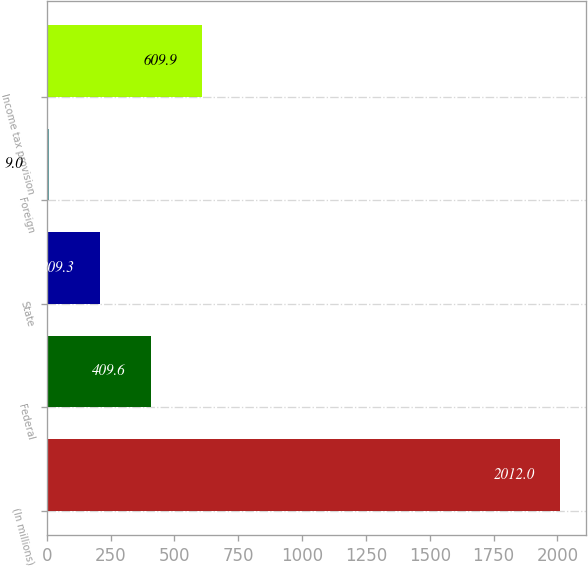<chart> <loc_0><loc_0><loc_500><loc_500><bar_chart><fcel>(In millions)<fcel>Federal<fcel>State<fcel>Foreign<fcel>Income tax provision<nl><fcel>2012<fcel>409.6<fcel>209.3<fcel>9<fcel>609.9<nl></chart> 